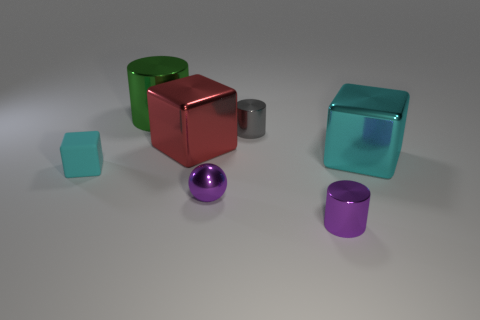Subtract all yellow cubes. Subtract all purple cylinders. How many cubes are left? 3 Add 2 red metal cubes. How many objects exist? 9 Subtract all balls. How many objects are left? 6 Add 2 large brown things. How many large brown things exist? 2 Subtract 0 green blocks. How many objects are left? 7 Subtract all gray things. Subtract all tiny purple shiny objects. How many objects are left? 4 Add 6 tiny purple shiny things. How many tiny purple shiny things are left? 8 